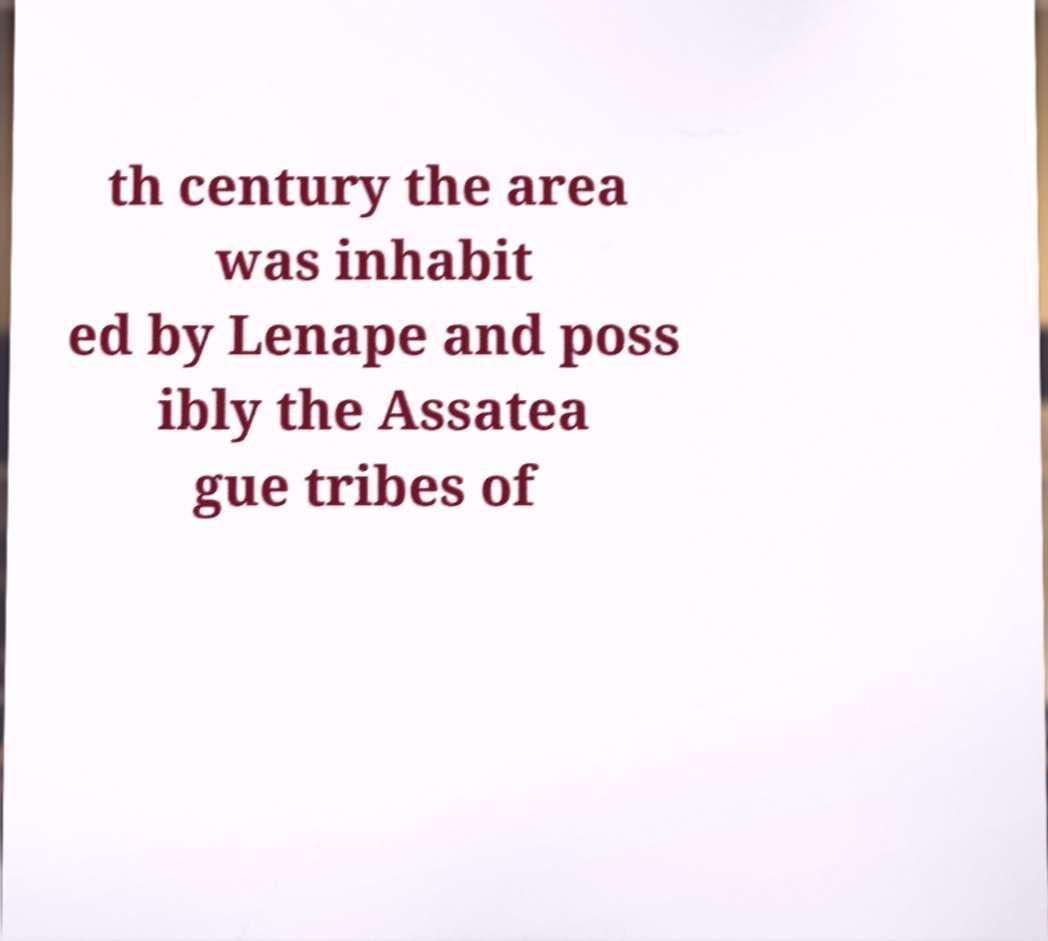Please identify and transcribe the text found in this image. th century the area was inhabit ed by Lenape and poss ibly the Assatea gue tribes of 